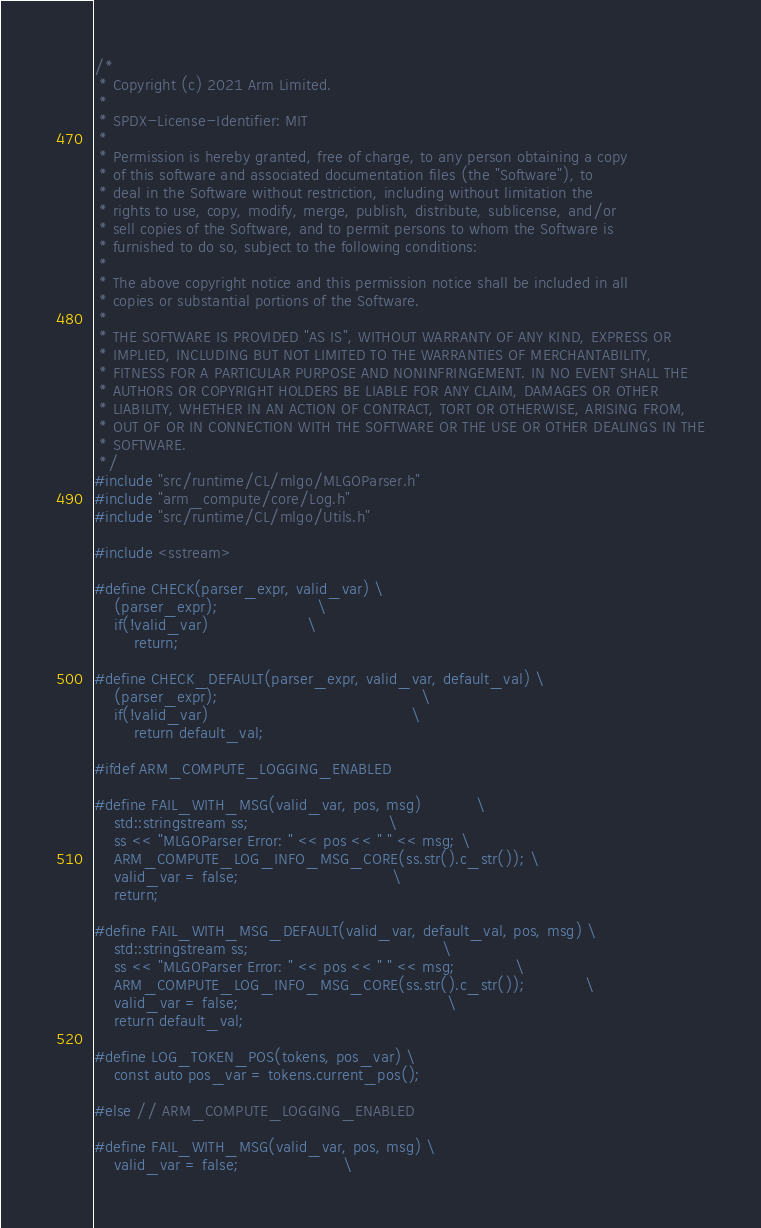<code> <loc_0><loc_0><loc_500><loc_500><_C++_>/*
 * Copyright (c) 2021 Arm Limited.
 *
 * SPDX-License-Identifier: MIT
 *
 * Permission is hereby granted, free of charge, to any person obtaining a copy
 * of this software and associated documentation files (the "Software"), to
 * deal in the Software without restriction, including without limitation the
 * rights to use, copy, modify, merge, publish, distribute, sublicense, and/or
 * sell copies of the Software, and to permit persons to whom the Software is
 * furnished to do so, subject to the following conditions:
 *
 * The above copyright notice and this permission notice shall be included in all
 * copies or substantial portions of the Software.
 *
 * THE SOFTWARE IS PROVIDED "AS IS", WITHOUT WARRANTY OF ANY KIND, EXPRESS OR
 * IMPLIED, INCLUDING BUT NOT LIMITED TO THE WARRANTIES OF MERCHANTABILITY,
 * FITNESS FOR A PARTICULAR PURPOSE AND NONINFRINGEMENT. IN NO EVENT SHALL THE
 * AUTHORS OR COPYRIGHT HOLDERS BE LIABLE FOR ANY CLAIM, DAMAGES OR OTHER
 * LIABILITY, WHETHER IN AN ACTION OF CONTRACT, TORT OR OTHERWISE, ARISING FROM,
 * OUT OF OR IN CONNECTION WITH THE SOFTWARE OR THE USE OR OTHER DEALINGS IN THE
 * SOFTWARE.
 */
#include "src/runtime/CL/mlgo/MLGOParser.h"
#include "arm_compute/core/Log.h"
#include "src/runtime/CL/mlgo/Utils.h"

#include <sstream>

#define CHECK(parser_expr, valid_var) \
    (parser_expr);                    \
    if(!valid_var)                    \
        return;

#define CHECK_DEFAULT(parser_expr, valid_var, default_val) \
    (parser_expr);                                         \
    if(!valid_var)                                         \
        return default_val;

#ifdef ARM_COMPUTE_LOGGING_ENABLED

#define FAIL_WITH_MSG(valid_var, pos, msg)           \
    std::stringstream ss;                            \
    ss << "MLGOParser Error: " << pos << " " << msg; \
    ARM_COMPUTE_LOG_INFO_MSG_CORE(ss.str().c_str()); \
    valid_var = false;                               \
    return;

#define FAIL_WITH_MSG_DEFAULT(valid_var, default_val, pos, msg) \
    std::stringstream ss;                                       \
    ss << "MLGOParser Error: " << pos << " " << msg;            \
    ARM_COMPUTE_LOG_INFO_MSG_CORE(ss.str().c_str());            \
    valid_var = false;                                          \
    return default_val;

#define LOG_TOKEN_POS(tokens, pos_var) \
    const auto pos_var = tokens.current_pos();

#else // ARM_COMPUTE_LOGGING_ENABLED

#define FAIL_WITH_MSG(valid_var, pos, msg) \
    valid_var = false;                     \</code> 